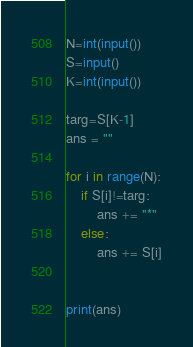Convert code to text. <code><loc_0><loc_0><loc_500><loc_500><_Python_>N=int(input())
S=input()
K=int(input())

targ=S[K-1]
ans = ""

for i in range(N):
	if S[i]!=targ:
		ans += "*"
	else:
		ans += S[i]


print(ans)</code> 